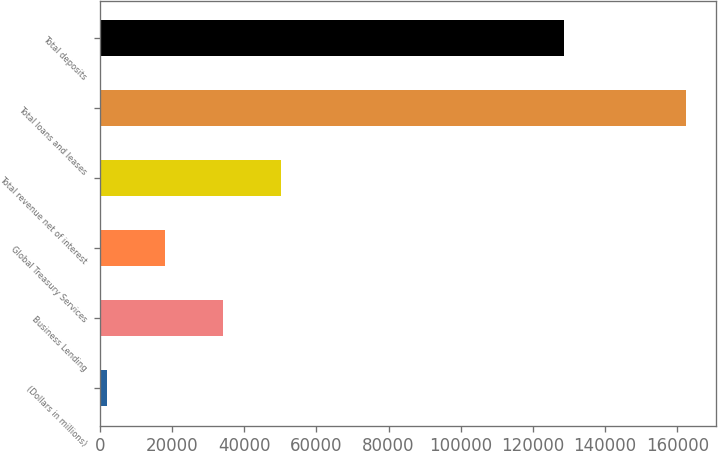<chart> <loc_0><loc_0><loc_500><loc_500><bar_chart><fcel>(Dollars in millions)<fcel>Business Lending<fcel>Global Treasury Services<fcel>Total revenue net of interest<fcel>Total loans and leases<fcel>Total deposits<nl><fcel>2011<fcel>34114<fcel>18062.5<fcel>50165.5<fcel>162526<fcel>128513<nl></chart> 